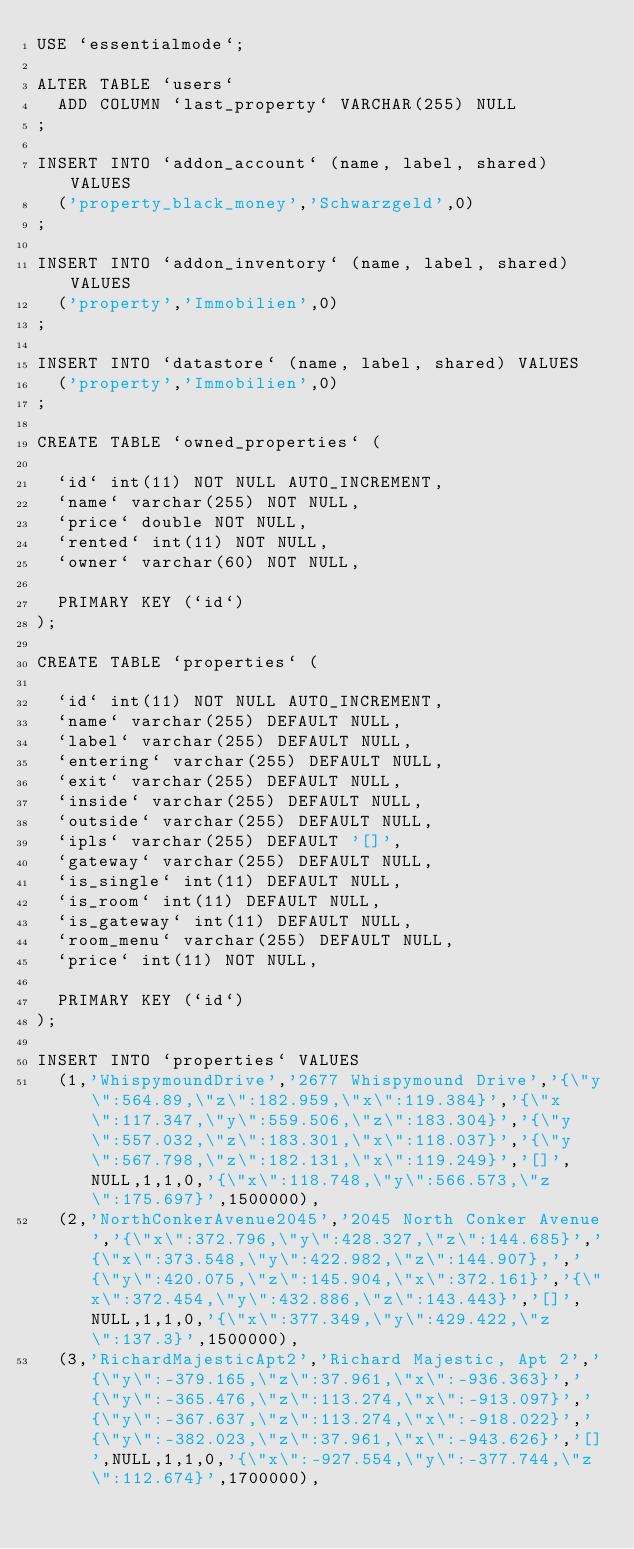Convert code to text. <code><loc_0><loc_0><loc_500><loc_500><_SQL_>USE `essentialmode`;

ALTER TABLE `users`
  ADD COLUMN `last_property` VARCHAR(255) NULL
;

INSERT INTO `addon_account` (name, label, shared) VALUES
  ('property_black_money','Schwarzgeld',0)
;

INSERT INTO `addon_inventory` (name, label, shared) VALUES
  ('property','Immobilien',0)
;

INSERT INTO `datastore` (name, label, shared) VALUES
  ('property','Immobilien',0)
;

CREATE TABLE `owned_properties` (

  `id` int(11) NOT NULL AUTO_INCREMENT,
  `name` varchar(255) NOT NULL,
  `price` double NOT NULL,
  `rented` int(11) NOT NULL,
  `owner` varchar(60) NOT NULL,

  PRIMARY KEY (`id`)
);

CREATE TABLE `properties` (

  `id` int(11) NOT NULL AUTO_INCREMENT,
  `name` varchar(255) DEFAULT NULL,
  `label` varchar(255) DEFAULT NULL,
  `entering` varchar(255) DEFAULT NULL,
  `exit` varchar(255) DEFAULT NULL,
  `inside` varchar(255) DEFAULT NULL,
  `outside` varchar(255) DEFAULT NULL,
  `ipls` varchar(255) DEFAULT '[]',
  `gateway` varchar(255) DEFAULT NULL,
  `is_single` int(11) DEFAULT NULL,
  `is_room` int(11) DEFAULT NULL,
  `is_gateway` int(11) DEFAULT NULL,
  `room_menu` varchar(255) DEFAULT NULL,
  `price` int(11) NOT NULL,

  PRIMARY KEY (`id`)
);

INSERT INTO `properties` VALUES
  (1,'WhispymoundDrive','2677 Whispymound Drive','{\"y\":564.89,\"z\":182.959,\"x\":119.384}','{\"x\":117.347,\"y\":559.506,\"z\":183.304}','{\"y\":557.032,\"z\":183.301,\"x\":118.037}','{\"y\":567.798,\"z\":182.131,\"x\":119.249}','[]',NULL,1,1,0,'{\"x\":118.748,\"y\":566.573,\"z\":175.697}',1500000),
  (2,'NorthConkerAvenue2045','2045 North Conker Avenue','{\"x\":372.796,\"y\":428.327,\"z\":144.685}','{\"x\":373.548,\"y\":422.982,\"z\":144.907},','{\"y\":420.075,\"z\":145.904,\"x\":372.161}','{\"x\":372.454,\"y\":432.886,\"z\":143.443}','[]',NULL,1,1,0,'{\"x\":377.349,\"y\":429.422,\"z\":137.3}',1500000),
  (3,'RichardMajesticApt2','Richard Majestic, Apt 2','{\"y\":-379.165,\"z\":37.961,\"x\":-936.363}','{\"y\":-365.476,\"z\":113.274,\"x\":-913.097}','{\"y\":-367.637,\"z\":113.274,\"x\":-918.022}','{\"y\":-382.023,\"z\":37.961,\"x\":-943.626}','[]',NULL,1,1,0,'{\"x\":-927.554,\"y\":-377.744,\"z\":112.674}',1700000),</code> 